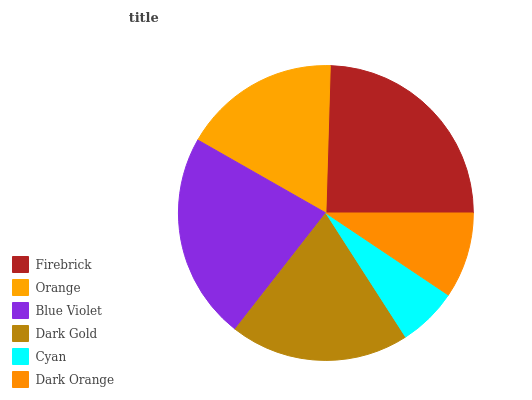Is Cyan the minimum?
Answer yes or no. Yes. Is Firebrick the maximum?
Answer yes or no. Yes. Is Orange the minimum?
Answer yes or no. No. Is Orange the maximum?
Answer yes or no. No. Is Firebrick greater than Orange?
Answer yes or no. Yes. Is Orange less than Firebrick?
Answer yes or no. Yes. Is Orange greater than Firebrick?
Answer yes or no. No. Is Firebrick less than Orange?
Answer yes or no. No. Is Dark Gold the high median?
Answer yes or no. Yes. Is Orange the low median?
Answer yes or no. Yes. Is Cyan the high median?
Answer yes or no. No. Is Dark Orange the low median?
Answer yes or no. No. 